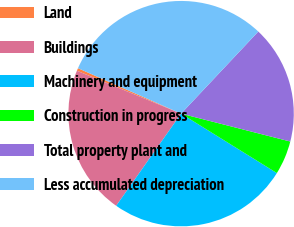<chart> <loc_0><loc_0><loc_500><loc_500><pie_chart><fcel>Land<fcel>Buildings<fcel>Machinery and equipment<fcel>Construction in progress<fcel>Total property plant and<fcel>Less accumulated depreciation<nl><fcel>0.39%<fcel>21.45%<fcel>25.93%<fcel>4.86%<fcel>16.97%<fcel>30.4%<nl></chart> 